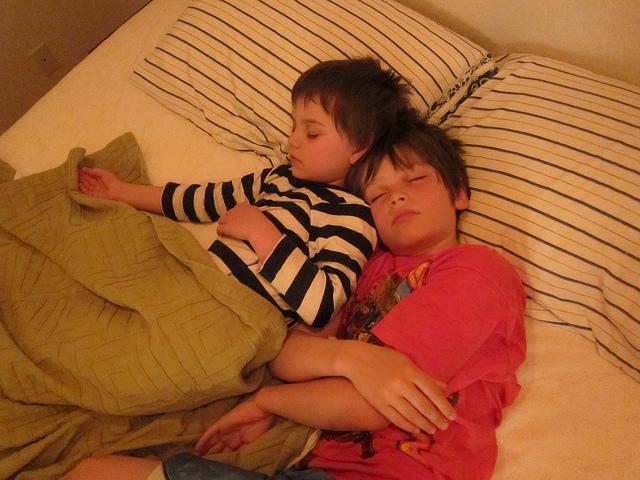How many people are there?
Give a very brief answer. 2. How many people are awake?
Give a very brief answer. 0. 